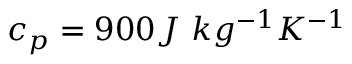Convert formula to latex. <formula><loc_0><loc_0><loc_500><loc_500>c _ { p } = 9 0 0 J \ k g ^ { - 1 } K ^ { - 1 }</formula> 